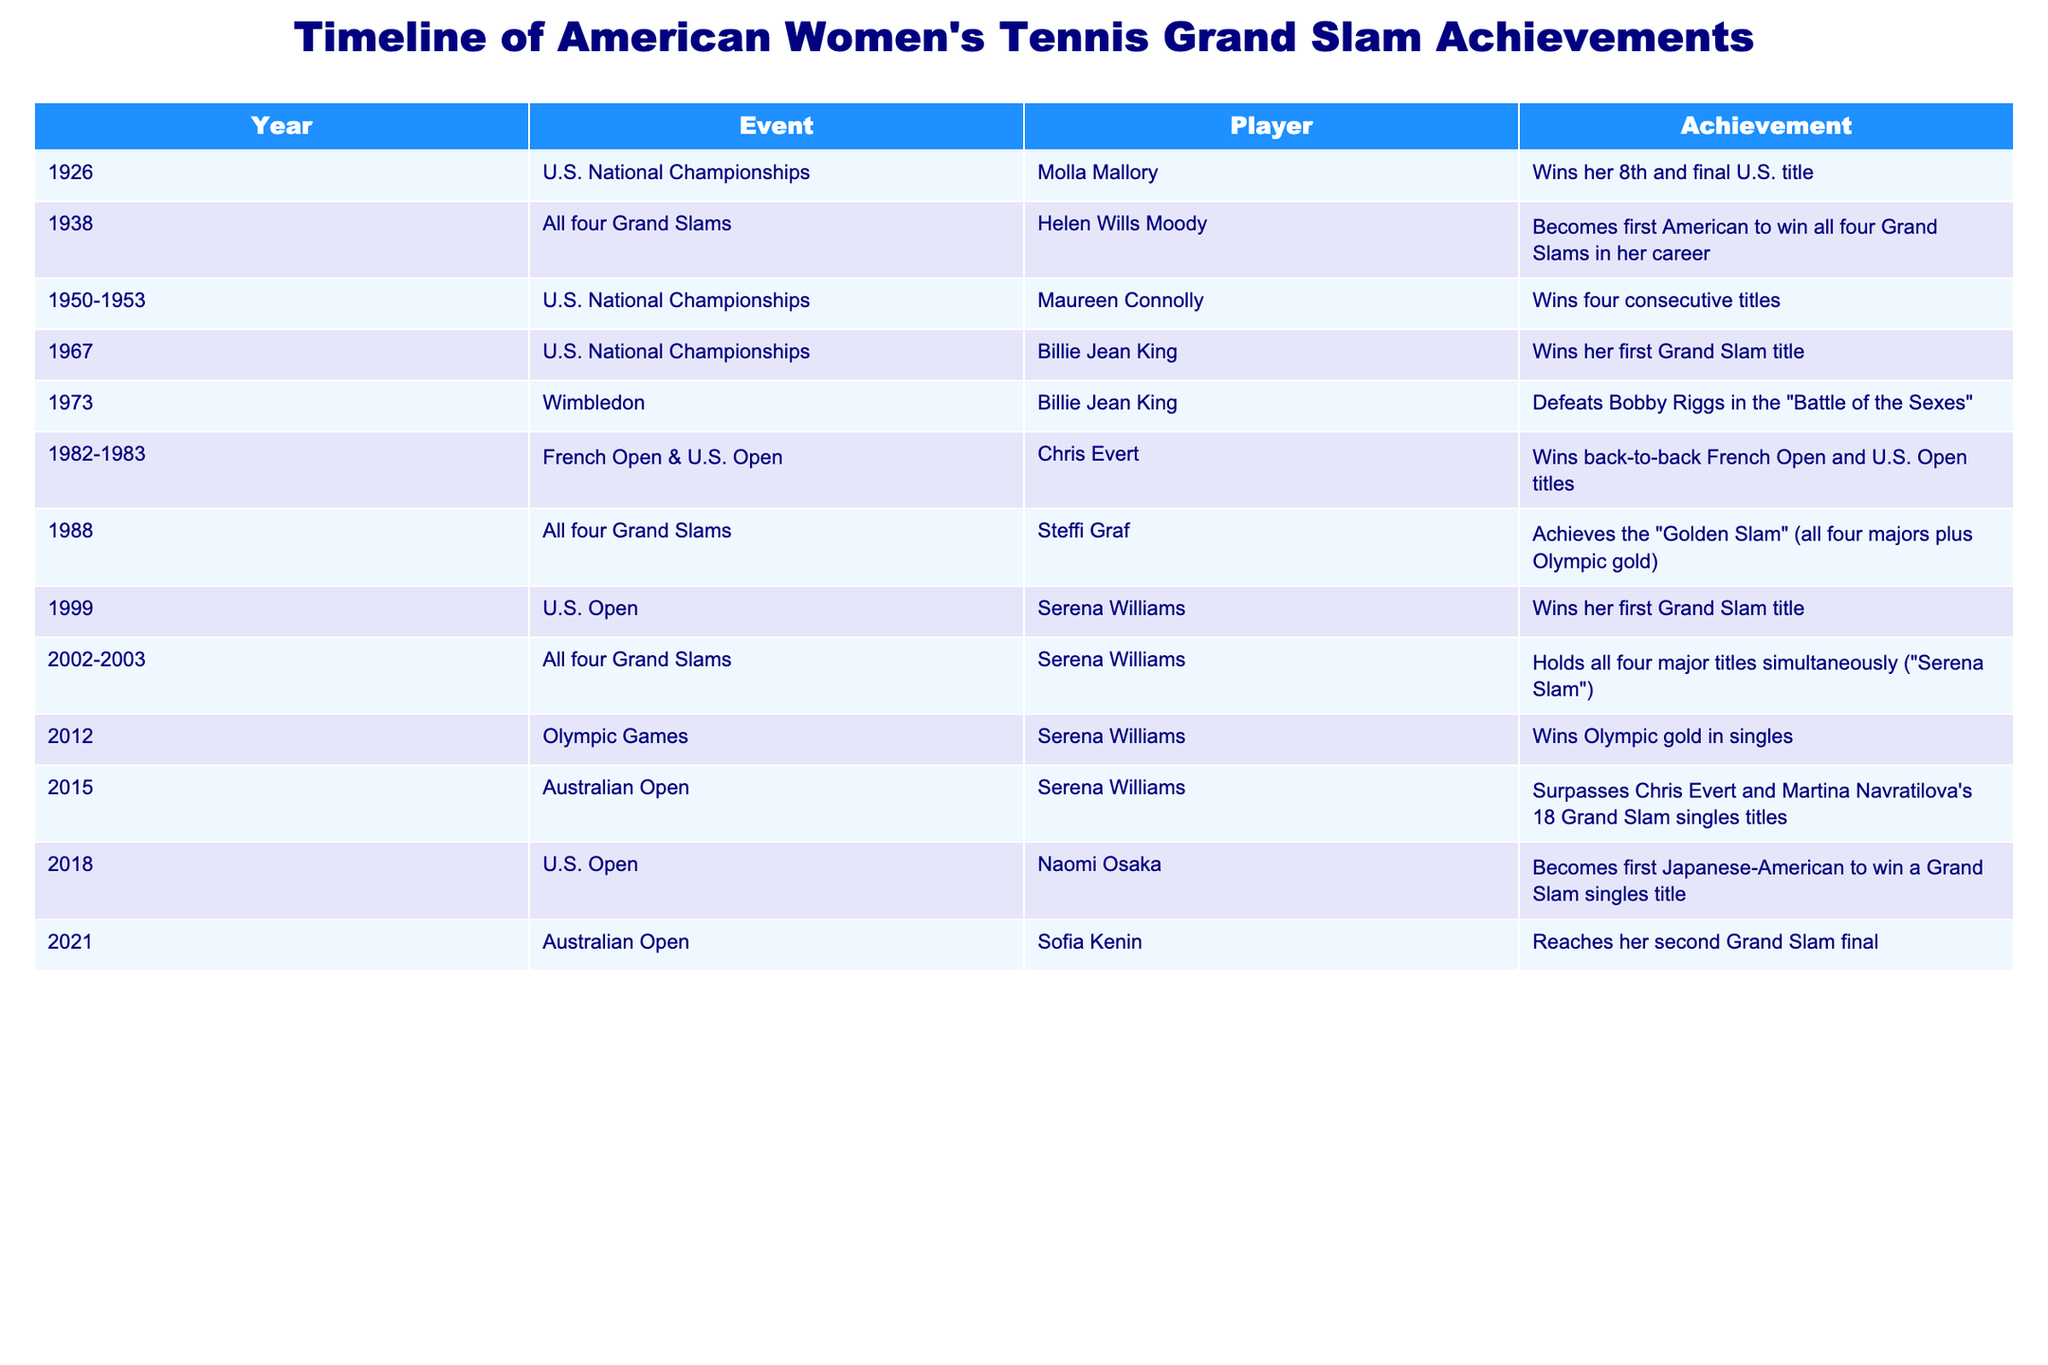What year did Billie Jean King win her first Grand Slam title? The table shows that Billie Jean King won her first Grand Slam title at the U.S. National Championships in the year 1967.
Answer: 1967 How many consecutive titles did Maureen Connolly win at the U.S. National Championships? According to the table, Maureen Connolly won four consecutive titles from 1950 to 1953.
Answer: Four Which player becomes the first American to win all four Grand Slams in her career? The table indicates that Helen Wills Moody became the first American to win all four Grand Slams in her career in 1938.
Answer: Helen Wills Moody Did Steffi Graf achieve the "Golden Slam"? The table states that Steffi Graf achieved the "Golden Slam" in 1988 by winning all four majors plus Olympic gold, which indicates that the statement is true.
Answer: Yes What is the total number of Grand Slam titles won by Serena Williams as of 2015? In the table, it shows that Serena Williams surpassed Chris Evert and Martina Navratilova's 18 Grand Slam singles titles in 2015, implying she has at least 19 titles by that year. Therefore, the total number of Grand Slam titles she won is 19 or more, considering she has titles before 2015.
Answer: 19 or more How many players won Grand Slam titles in the 2000s decade? The table lists three players achieving Grand Slam titles in the 2000s: Serena Williams (1999), her simultaneous titles (2002-2003), and Naomi Osaka (2018). While it's a bit ambiguous due to overlapping years, the implied important Grand Slam achievements confirm that at least two distinct players (Serena Williams, Naomi Osaka) are accounted for. Thus, the distinct players who won in that decade are Serena Williams and Naomi Osaka, equaling two distinct occurrences.
Answer: 2 Which player won the U.S. Open in 2018? From the table, it is noted that Naomi Osaka won the U.S. Open in 2018, as listed clearly in the event and player columns.
Answer: Naomi Osaka In how many different Grand Slam tournaments did Chris Evert win titles back-to-back? The table indicates that Chris Evert won back-to-back titles at both the French Open and U.S. Open in 1982 and 1983 respectively, implying she won titles in two different tournaments in this consecutive manner.
Answer: 2 